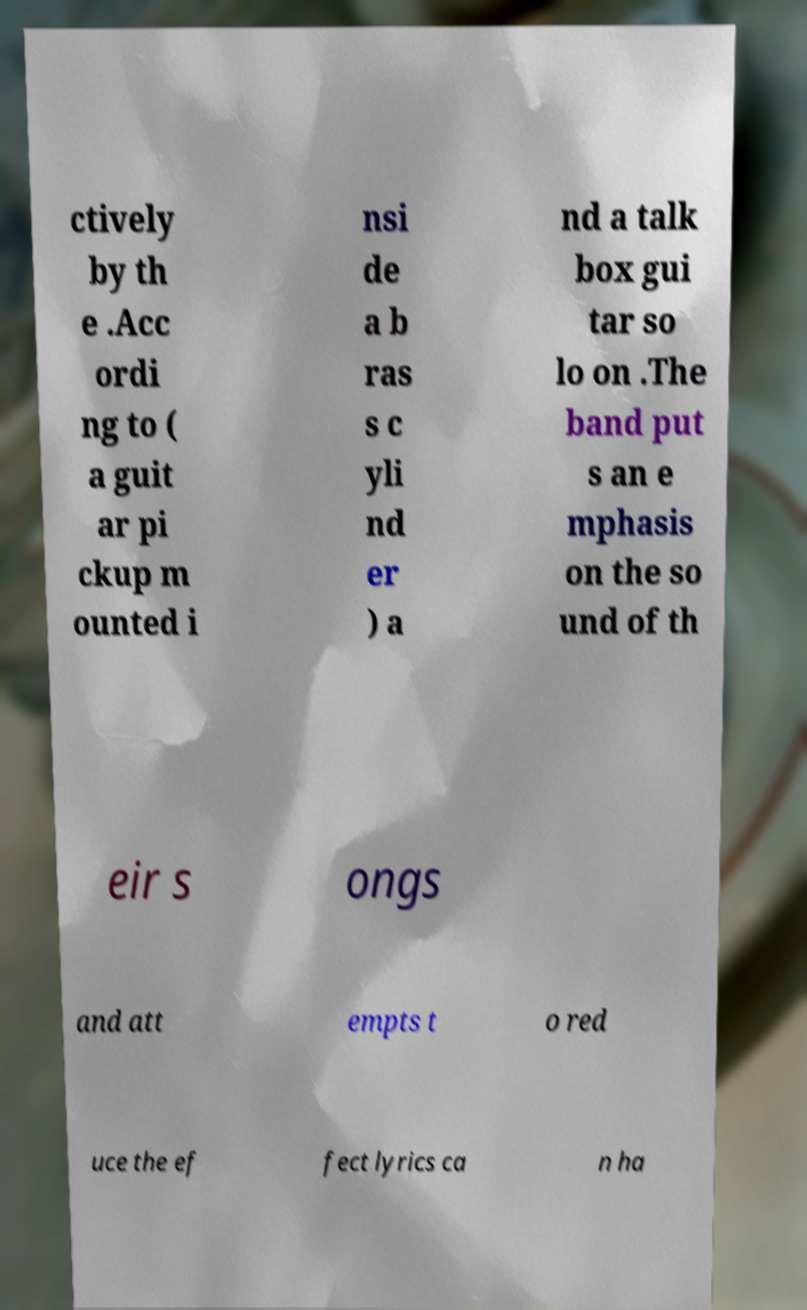Could you extract and type out the text from this image? ctively by th e .Acc ordi ng to ( a guit ar pi ckup m ounted i nsi de a b ras s c yli nd er ) a nd a talk box gui tar so lo on .The band put s an e mphasis on the so und of th eir s ongs and att empts t o red uce the ef fect lyrics ca n ha 